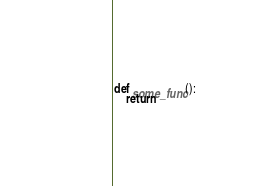Convert code to text. <code><loc_0><loc_0><loc_500><loc_500><_Python_>def some_func():
    return
</code> 